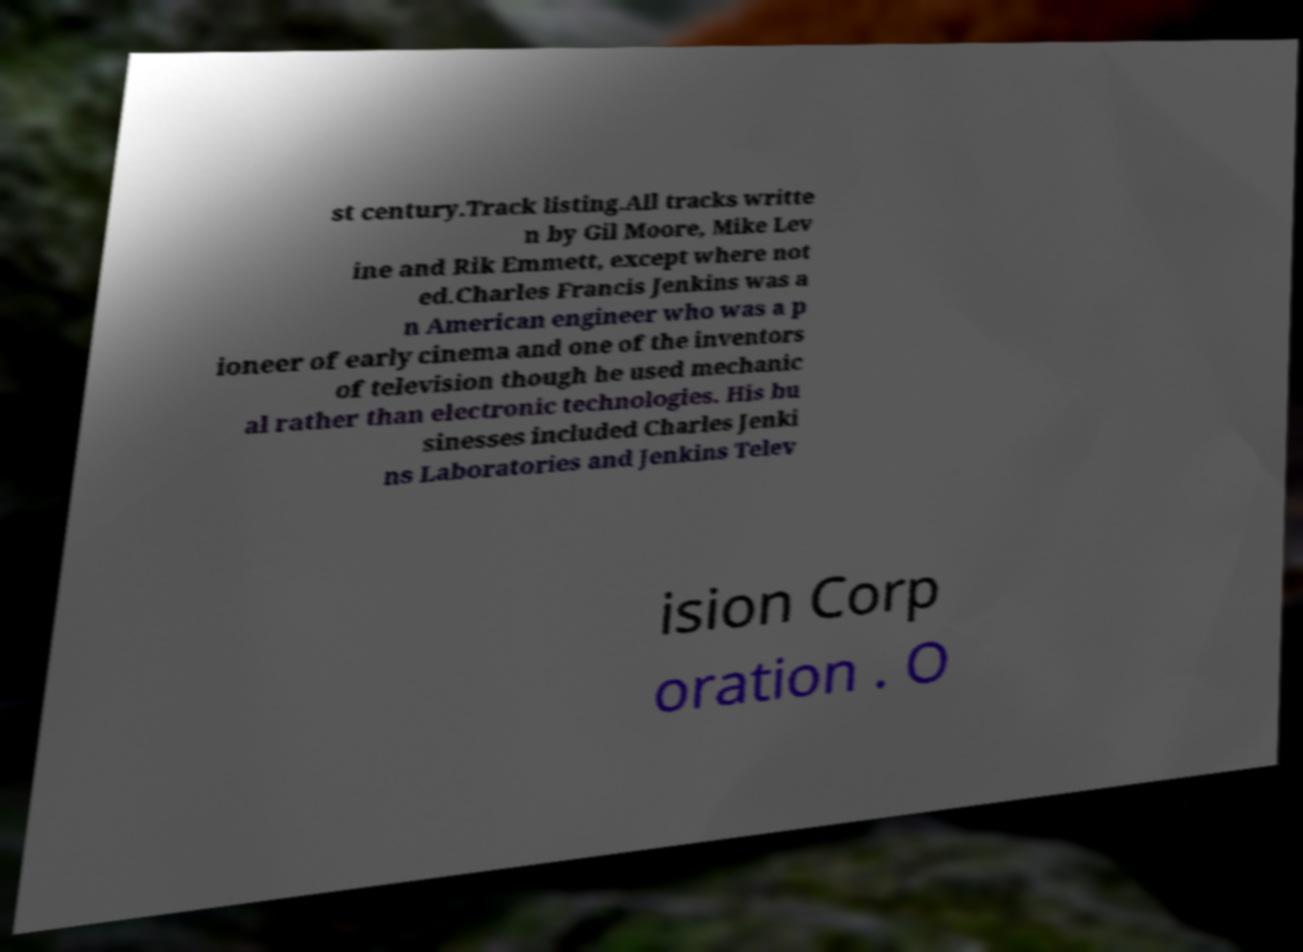For documentation purposes, I need the text within this image transcribed. Could you provide that? st century.Track listing.All tracks writte n by Gil Moore, Mike Lev ine and Rik Emmett, except where not ed.Charles Francis Jenkins was a n American engineer who was a p ioneer of early cinema and one of the inventors of television though he used mechanic al rather than electronic technologies. His bu sinesses included Charles Jenki ns Laboratories and Jenkins Telev ision Corp oration . O 